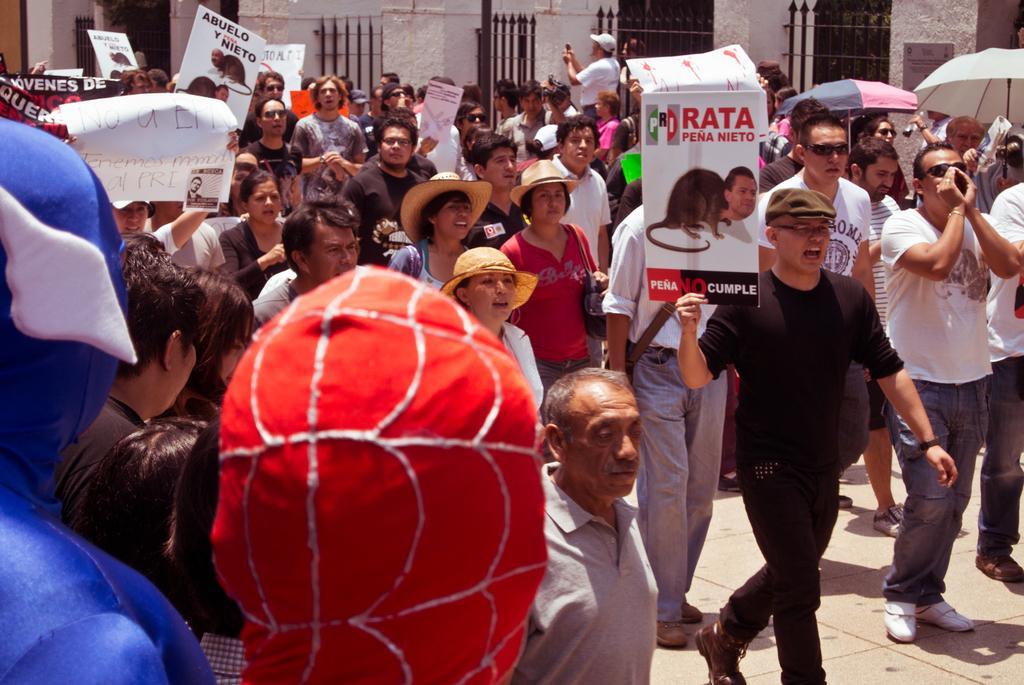Can you describe this image briefly? This picture is clicked outside the city. In this picture, we see many people are walking on the road. Here, we see most of them are holding white boards with some text written on it. The man in white T-shirt is holding a white banner with some text written on it. On the right side, we see some people are holding umbrellas. At the bottom of the picture, we see two men are wearing blue and red costume. In the background, we see a wall and railings. 